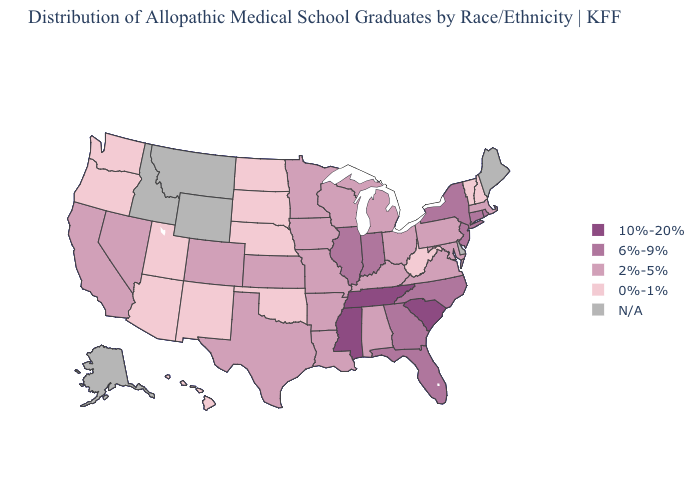Among the states that border Missouri , does Iowa have the highest value?
Give a very brief answer. No. Does the first symbol in the legend represent the smallest category?
Write a very short answer. No. Which states hav the highest value in the MidWest?
Concise answer only. Illinois, Indiana. Name the states that have a value in the range 6%-9%?
Concise answer only. Connecticut, Florida, Georgia, Illinois, Indiana, New Jersey, New York, North Carolina, Rhode Island. Name the states that have a value in the range 2%-5%?
Be succinct. Alabama, Arkansas, California, Colorado, Iowa, Kansas, Kentucky, Louisiana, Maryland, Massachusetts, Michigan, Minnesota, Missouri, Nevada, Ohio, Pennsylvania, Texas, Virginia, Wisconsin. Name the states that have a value in the range 2%-5%?
Short answer required. Alabama, Arkansas, California, Colorado, Iowa, Kansas, Kentucky, Louisiana, Maryland, Massachusetts, Michigan, Minnesota, Missouri, Nevada, Ohio, Pennsylvania, Texas, Virginia, Wisconsin. What is the value of Georgia?
Be succinct. 6%-9%. What is the lowest value in states that border Vermont?
Keep it brief. 0%-1%. What is the value of Kansas?
Write a very short answer. 2%-5%. Does the map have missing data?
Keep it brief. Yes. What is the highest value in states that border North Dakota?
Answer briefly. 2%-5%. Name the states that have a value in the range 6%-9%?
Quick response, please. Connecticut, Florida, Georgia, Illinois, Indiana, New Jersey, New York, North Carolina, Rhode Island. Among the states that border Indiana , does Illinois have the highest value?
Quick response, please. Yes. What is the lowest value in the Northeast?
Keep it brief. 0%-1%. 